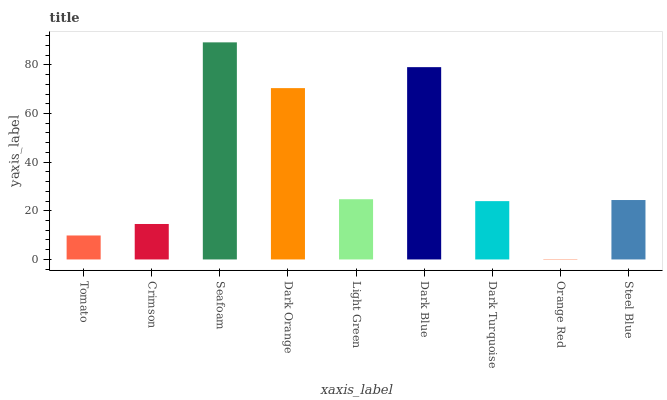Is Orange Red the minimum?
Answer yes or no. Yes. Is Seafoam the maximum?
Answer yes or no. Yes. Is Crimson the minimum?
Answer yes or no. No. Is Crimson the maximum?
Answer yes or no. No. Is Crimson greater than Tomato?
Answer yes or no. Yes. Is Tomato less than Crimson?
Answer yes or no. Yes. Is Tomato greater than Crimson?
Answer yes or no. No. Is Crimson less than Tomato?
Answer yes or no. No. Is Steel Blue the high median?
Answer yes or no. Yes. Is Steel Blue the low median?
Answer yes or no. Yes. Is Dark Turquoise the high median?
Answer yes or no. No. Is Dark Blue the low median?
Answer yes or no. No. 